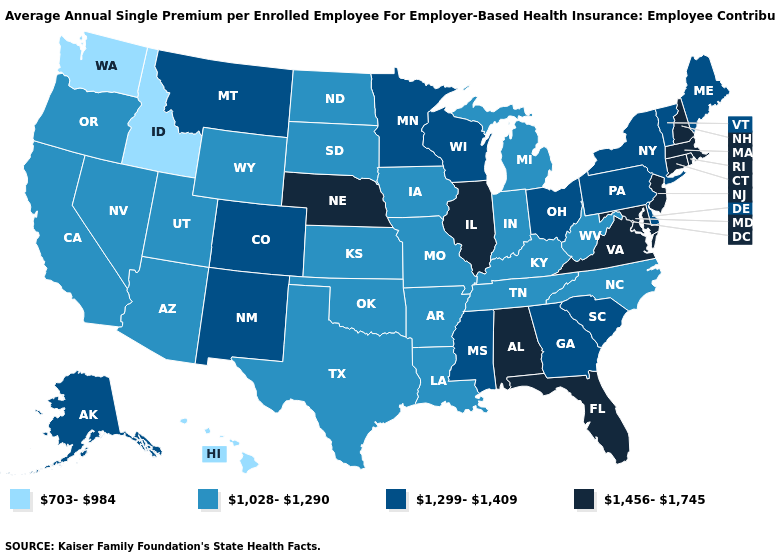Name the states that have a value in the range 1,456-1,745?
Keep it brief. Alabama, Connecticut, Florida, Illinois, Maryland, Massachusetts, Nebraska, New Hampshire, New Jersey, Rhode Island, Virginia. Among the states that border Kentucky , which have the highest value?
Keep it brief. Illinois, Virginia. Among the states that border South Dakota , does Wyoming have the lowest value?
Concise answer only. Yes. Does Connecticut have the lowest value in the Northeast?
Quick response, please. No. Name the states that have a value in the range 1,456-1,745?
Keep it brief. Alabama, Connecticut, Florida, Illinois, Maryland, Massachusetts, Nebraska, New Hampshire, New Jersey, Rhode Island, Virginia. What is the value of Missouri?
Quick response, please. 1,028-1,290. What is the lowest value in states that border Maine?
Short answer required. 1,456-1,745. Does Massachusetts have the lowest value in the Northeast?
Quick response, please. No. What is the value of Utah?
Keep it brief. 1,028-1,290. What is the value of Iowa?
Short answer required. 1,028-1,290. Name the states that have a value in the range 1,456-1,745?
Quick response, please. Alabama, Connecticut, Florida, Illinois, Maryland, Massachusetts, Nebraska, New Hampshire, New Jersey, Rhode Island, Virginia. What is the value of Tennessee?
Give a very brief answer. 1,028-1,290. What is the lowest value in states that border Washington?
Concise answer only. 703-984. Does Minnesota have the lowest value in the MidWest?
Be succinct. No. 